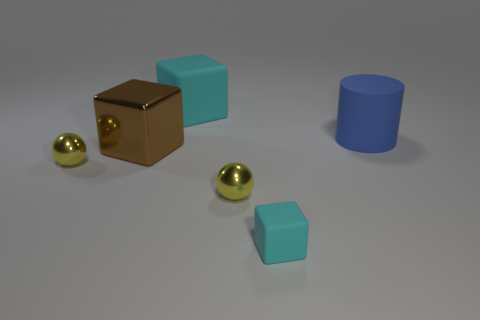Add 1 large red metal objects. How many objects exist? 7 Subtract all cylinders. How many objects are left? 5 Add 3 blocks. How many blocks exist? 6 Subtract 1 cyan cubes. How many objects are left? 5 Subtract all big green matte cylinders. Subtract all tiny metal balls. How many objects are left? 4 Add 1 blue rubber things. How many blue rubber things are left? 2 